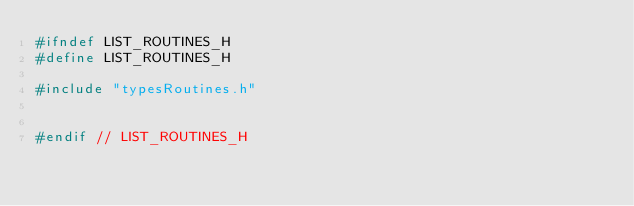Convert code to text. <code><loc_0><loc_0><loc_500><loc_500><_C_>#ifndef LIST_ROUTINES_H
#define LIST_ROUTINES_H

#include "typesRoutines.h"


#endif // LIST_ROUTINES_H
</code> 